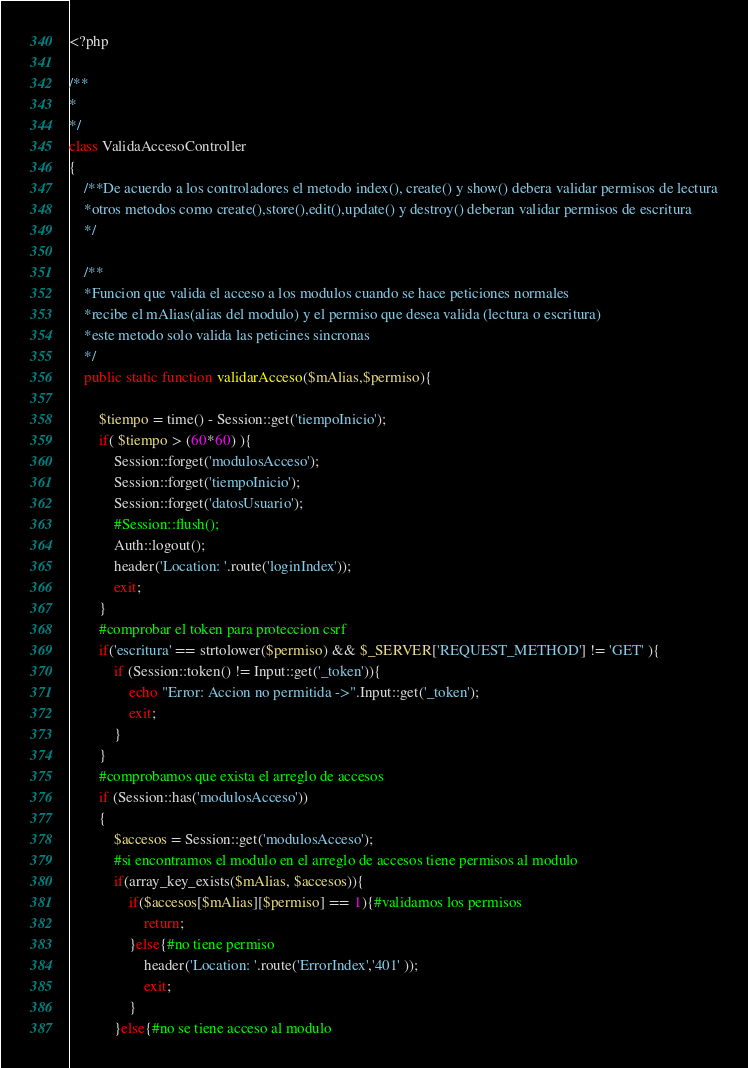<code> <loc_0><loc_0><loc_500><loc_500><_PHP_><?php  

/**
* 
*/
class ValidaAccesoController 
{
	/**De acuerdo a los controladores el metodo index(), create() y show() debera validar permisos de lectura
	*otros metodos como create(),store(),edit(),update() y destroy() deberan validar permisos de escritura
	*/

	/**
	*Funcion que valida el acceso a los modulos cuando se hace peticiones normales
	*recibe el mAlias(alias del modulo) y el permiso que desea valida (lectura o escritura)
	*este metodo solo valida las peticines sincronas
	*/
	public static function validarAcceso($mAlias,$permiso){
		
		$tiempo = time() - Session::get('tiempoInicio');
		if( $tiempo > (60*60) ){
			Session::forget('modulosAcceso');
			Session::forget('tiempoInicio');
			Session::forget('datosUsuario');
			#Session::flush();
			Auth::logout();
			header('Location: '.route('loginIndex'));
		    exit;
		}
		#comprobar el token para proteccion csrf
		if('escritura' == strtolower($permiso) && $_SERVER['REQUEST_METHOD'] != 'GET' ){
			if (Session::token() != Input::get('_token')){
				echo "Error: Accion no permitida ->".Input::get('_token');
				exit;
			}
		}
		#comprobamos que exista el arreglo de accesos
		if (Session::has('modulosAcceso'))
		{
			$accesos = Session::get('modulosAcceso');
		    #si encontramos el modulo en el arreglo de accesos tiene permisos al modulo
		    if(array_key_exists($mAlias, $accesos)){
		    	if($accesos[$mAlias][$permiso] == 1){#validamos los permisos
		    		return;
		    	}else{#no tiene permiso
		    		header('Location: '.route('ErrorIndex','401' ));
		    		exit;
		    	}
		    }else{#no se tiene acceso al modulo</code> 